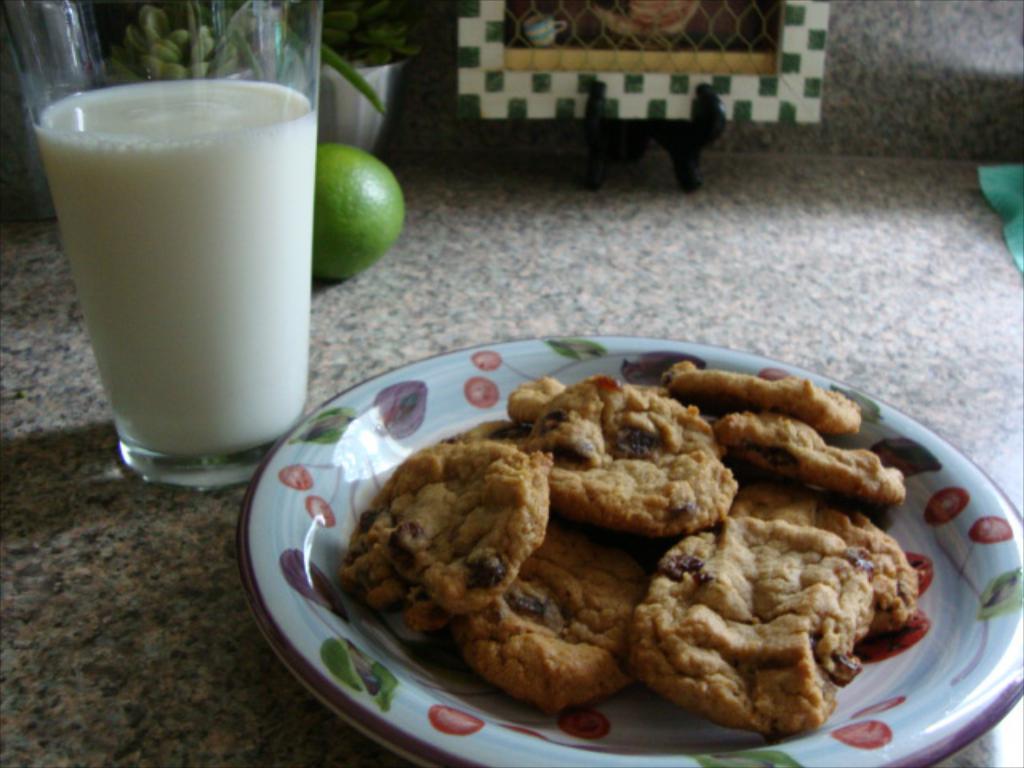Describe this image in one or two sentences. In the center of the image we can see one table. On the table, we can see one plate, glass, bowl, cloth, one orange, plant and one green and white color object. In the plate, we can see a few cookies. In the glass, we can see some milk. In the background there is a wall. 